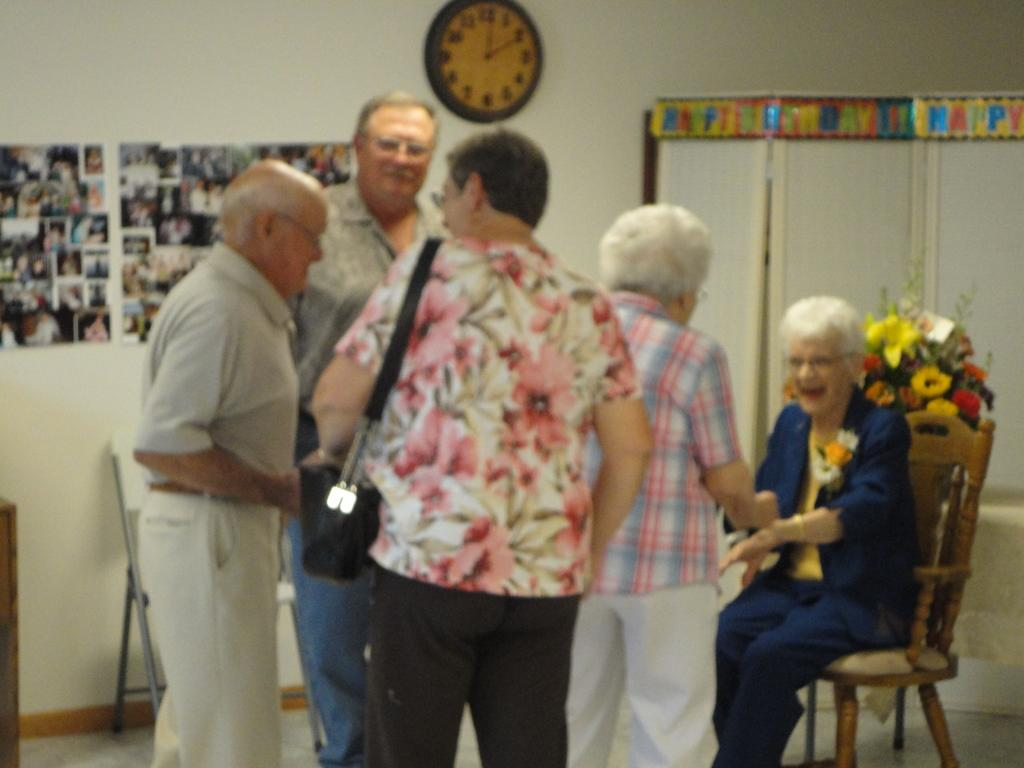Provide a one-sentence caption for the provided image. A happy birthday banner hangs over the windows in a group meeting room. 